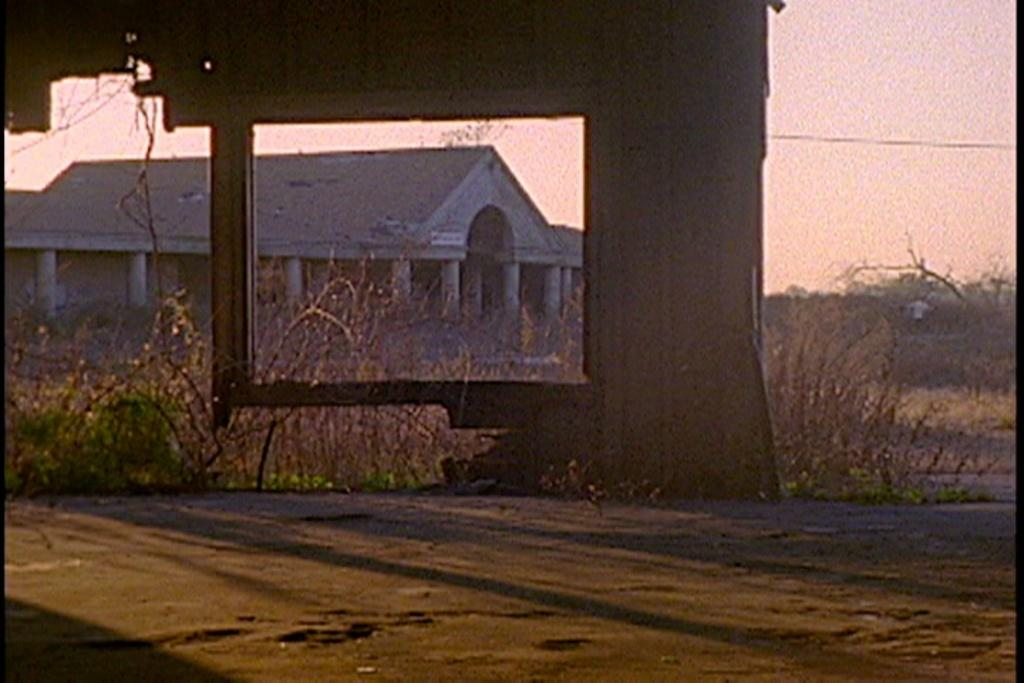What is present in the image that separates two areas? There is a wall in the image. What is the condition of the wall? The wall is broken. What can be seen behind the wall? There are plants and a building visible behind the wall. What part of the natural environment is visible in the image? The sky is visible in the top right corner of the image. Can you tell me how many insects are crawling on the expert's government-issued hat in the image? There are no insects, experts, or government-issued hats present in the image. 